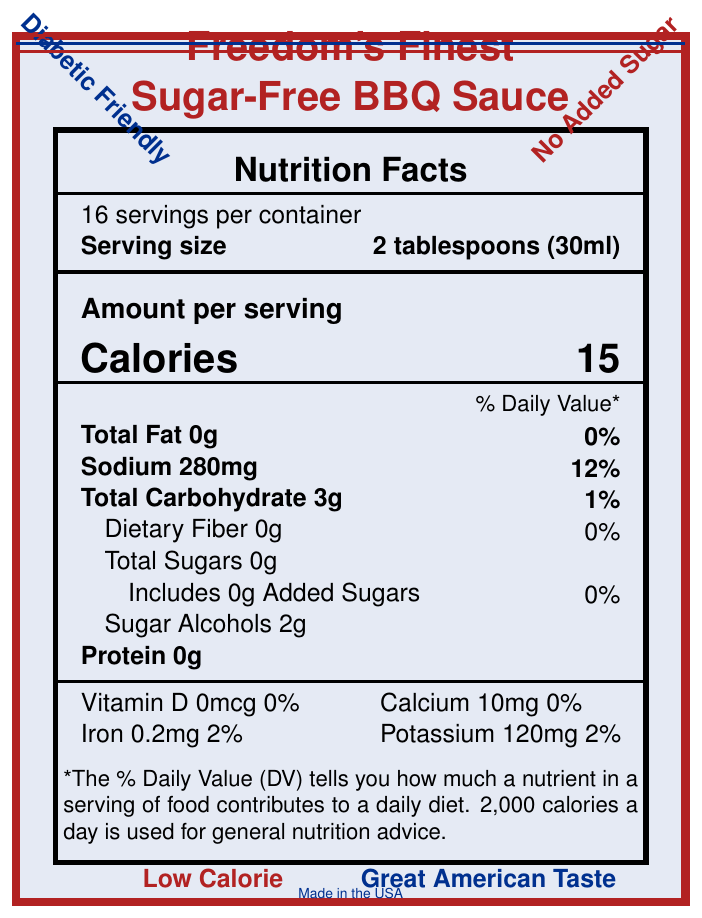what is the serving size? The serving size is stated as "2 tablespoons (30ml)" in the Nutrition Facts section.
Answer: 2 tablespoons (30ml) How many calories are in one serving? It mentions "Calories 15" in the Amount per serving section.
Answer: 15 What percentage of the daily value for sodium does one serving contain? In the Nutrition Facts section, it lists "Sodium 280mg 12%".
Answer: 12% What is the total carbohydrate content per serving? The "Total Carbohydrate" amount is specified as 3g in the Nutrition Facts.
Answer: 3g Does the product contain any added sugars? The ingredient list includes "Includes 0g Added Sugars" showing that there are no added sugars.
Answer: No What are the main ingredients in the product? The ingredients list: "Tomato puree (water, tomato paste), apple cider vinegar, erythritol, salt, spices (including paprika), onion powder, garlic powder, natural smoke flavor, xanthan gum, sucralose".
Answer: Tomato puree, apple cider vinegar, erythritol, salt, spices, onion powder, garlic powder, natural smoke flavor, xanthan gum, sucralose What should you do with the sauce after opening it? The storage instructions clearly state "Refrigerate after opening".
Answer: Refrigerate after opening Where is the product manufactured? The manufacturer is "Heartland Foods, Inc., Kansas City, MO 64106" as listed at the bottom of the document.
Answer: Kansas City, MO 64106 How many servings are in one container? The label mentions "16 servings per container" in the Nutrition Facts.
Answer: 16 what is the purpose of the red, white, and blue label design? The description mentions "Red, white, and blue label design" indicating it's designed with patriotic elements.
Answer: Patriotic elements Which nutrient provides some amount of the daily value but not 0%? A. Vitamin D B. Calcium C. Iron D. Protein Iron provides 2% of the daily value, unlike Vitamin D, Calcium, and Protein which either have 0% or are not listed with a daily value.
Answer: C. Iron Which of the following is a health claim made by the product? A. High in Fiber B. Suitable for low-carb diets C. Contains artificial preservatives The health claims listed mention "Suitable for low-carb diets".
Answer: B. Suitable for low-carb diets Is this product suitable for people with diabetes? One of the bold callouts explicitly states "Diabetic Friendly".
Answer: Yes Summary question: Describe the main nutritional and marketing information presented on the label. The document presents detailed nutritional information highlighting the low-calorie, sugar-free attributes of the product, and emphasizes its suitability for diabetic and low-carb diets. Patriotic design elements tie in with the branding, and storage instructions along with manufacturing and customer service details are provided.
Answer: Freedom's Finest Sugar-Free BBQ Sauce offers a low-calorie, sugar-free condiment that is diabetic-friendly and has no added sugars. The label showcases nutritional facts highlighting minimal calories and carbs, no fats or proteins, and lists sodium, vitamins, and minerals content. Marketing claims include being made in the USA, gluten-free, and suitable for low-carb diets, with patriotic design elements like the American flag. What is the source of protein in this product? The visual information in the document does not specify a source of protein; it only indicates that the product contains 0g of protein.
Answer: Not enough information 